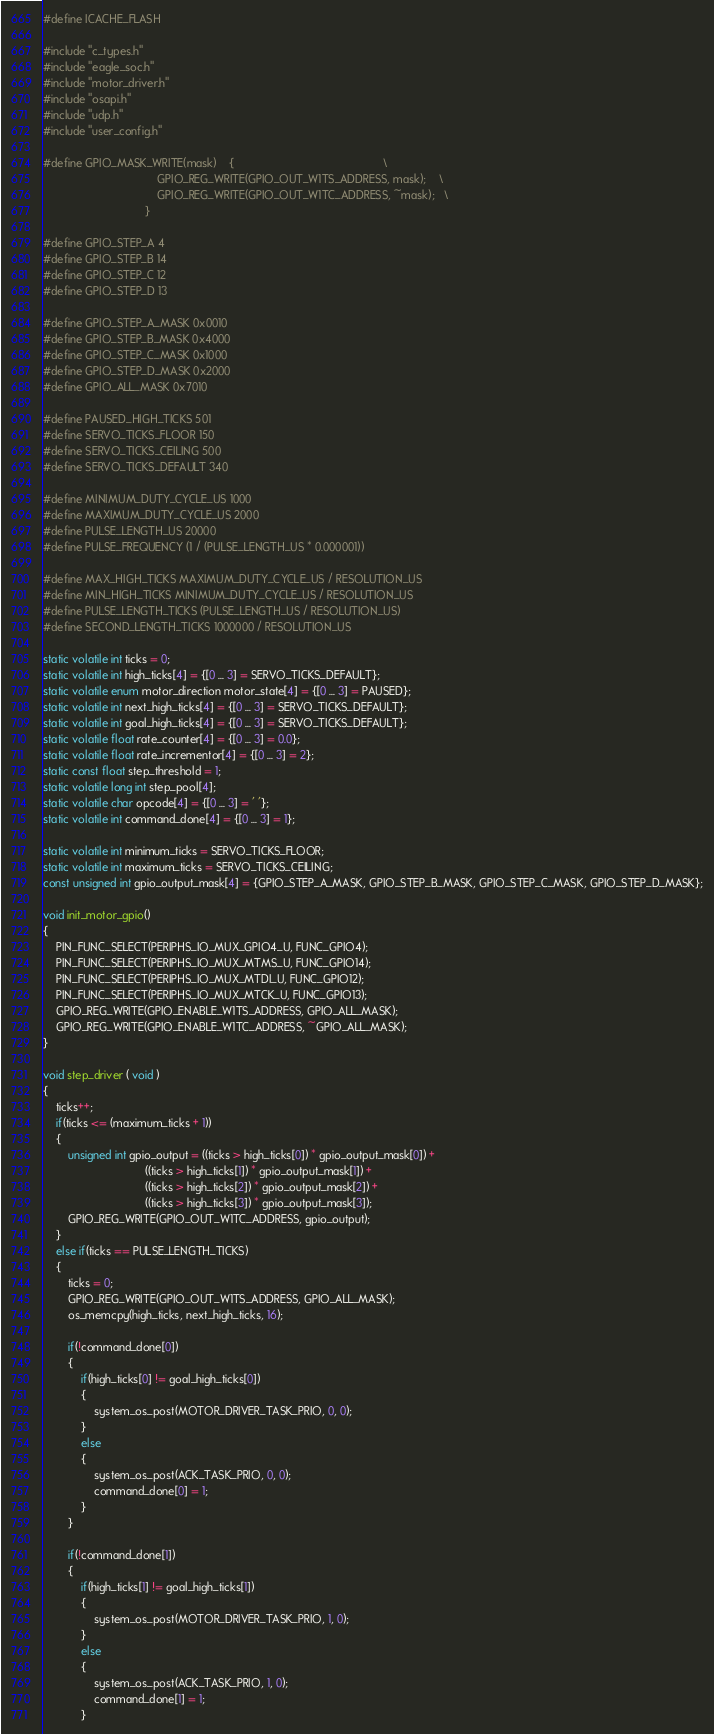Convert code to text. <code><loc_0><loc_0><loc_500><loc_500><_C_>#define ICACHE_FLASH

#include "c_types.h"
#include "eagle_soc.h"
#include "motor_driver.h"
#include "osapi.h"
#include "udp.h"
#include "user_config.h"

#define GPIO_MASK_WRITE(mask)	{												\
									GPIO_REG_WRITE(GPIO_OUT_W1TS_ADDRESS, mask);	\
									GPIO_REG_WRITE(GPIO_OUT_W1TC_ADDRESS, ~mask);	\
								}

#define GPIO_STEP_A 4
#define GPIO_STEP_B 14
#define GPIO_STEP_C 12
#define GPIO_STEP_D 13

#define GPIO_STEP_A_MASK 0x0010
#define GPIO_STEP_B_MASK 0x4000
#define GPIO_STEP_C_MASK 0x1000
#define GPIO_STEP_D_MASK 0x2000
#define GPIO_ALL_MASK 0x7010

#define PAUSED_HIGH_TICKS 501
#define SERVO_TICKS_FLOOR 150
#define SERVO_TICKS_CEILING 500
#define SERVO_TICKS_DEFAULT 340

#define MINIMUM_DUTY_CYCLE_US 1000
#define MAXIMUM_DUTY_CYCLE_US 2000
#define PULSE_LENGTH_US 20000
#define PULSE_FREQUENCY (1 / (PULSE_LENGTH_US * 0.000001))

#define MAX_HIGH_TICKS MAXIMUM_DUTY_CYCLE_US / RESOLUTION_US
#define MIN_HIGH_TICKS MINIMUM_DUTY_CYCLE_US / RESOLUTION_US
#define PULSE_LENGTH_TICKS (PULSE_LENGTH_US / RESOLUTION_US)
#define SECOND_LENGTH_TICKS 1000000 / RESOLUTION_US

static volatile int ticks = 0;
static volatile int high_ticks[4] = {[0 ... 3] = SERVO_TICKS_DEFAULT};
static volatile enum motor_direction motor_state[4] = {[0 ... 3] = PAUSED};
static volatile int next_high_ticks[4] = {[0 ... 3] = SERVO_TICKS_DEFAULT};
static volatile int goal_high_ticks[4] = {[0 ... 3] = SERVO_TICKS_DEFAULT};
static volatile float rate_counter[4] = {[0 ... 3] = 0.0}; 
static volatile float rate_incrementor[4] = {[0 ... 3] = 2};
static const float step_threshold = 1;
static volatile long int step_pool[4];
static volatile char opcode[4] = {[0 ... 3] = ' '};
static volatile int command_done[4] = {[0 ... 3] = 1};

static volatile int minimum_ticks = SERVO_TICKS_FLOOR;
static volatile int maximum_ticks = SERVO_TICKS_CEILING;
const unsigned int gpio_output_mask[4] = {GPIO_STEP_A_MASK, GPIO_STEP_B_MASK, GPIO_STEP_C_MASK, GPIO_STEP_D_MASK};

void init_motor_gpio()
{
	PIN_FUNC_SELECT(PERIPHS_IO_MUX_GPIO4_U, FUNC_GPIO4);
	PIN_FUNC_SELECT(PERIPHS_IO_MUX_MTMS_U, FUNC_GPIO14);
	PIN_FUNC_SELECT(PERIPHS_IO_MUX_MTDI_U, FUNC_GPIO12);
	PIN_FUNC_SELECT(PERIPHS_IO_MUX_MTCK_U, FUNC_GPIO13);
	GPIO_REG_WRITE(GPIO_ENABLE_W1TS_ADDRESS, GPIO_ALL_MASK);
	GPIO_REG_WRITE(GPIO_ENABLE_W1TC_ADDRESS, ~GPIO_ALL_MASK);
}

void step_driver ( void )
{
	ticks++;
	if(ticks <= (maximum_ticks + 1))
	{
		unsigned int gpio_output = ((ticks > high_ticks[0]) * gpio_output_mask[0]) +
								((ticks > high_ticks[1]) * gpio_output_mask[1]) +
								((ticks > high_ticks[2]) * gpio_output_mask[2]) +
								((ticks > high_ticks[3]) * gpio_output_mask[3]);
		GPIO_REG_WRITE(GPIO_OUT_W1TC_ADDRESS, gpio_output);
	}
	else if(ticks == PULSE_LENGTH_TICKS)
	{
		ticks = 0;
		GPIO_REG_WRITE(GPIO_OUT_W1TS_ADDRESS, GPIO_ALL_MASK);
		os_memcpy(high_ticks, next_high_ticks, 16);

		if(!command_done[0])
		{
			if(high_ticks[0] != goal_high_ticks[0])
			{
				system_os_post(MOTOR_DRIVER_TASK_PRIO, 0, 0);
			}
			else
			{
				system_os_post(ACK_TASK_PRIO, 0, 0);
				command_done[0] = 1;
			}
		}

		if(!command_done[1])
		{
			if(high_ticks[1] != goal_high_ticks[1])
			{
				system_os_post(MOTOR_DRIVER_TASK_PRIO, 1, 0);
			}
			else
			{
				system_os_post(ACK_TASK_PRIO, 1, 0);
				command_done[1] = 1;
			}</code> 